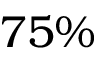Convert formula to latex. <formula><loc_0><loc_0><loc_500><loc_500>7 5 \%</formula> 